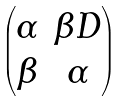Convert formula to latex. <formula><loc_0><loc_0><loc_500><loc_500>\begin{pmatrix} \alpha & \beta D \\ \beta & \alpha \end{pmatrix}</formula> 